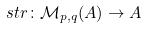Convert formula to latex. <formula><loc_0><loc_0><loc_500><loc_500>\ s t r \colon \mathcal { M } _ { p , q } ( A ) \to A</formula> 